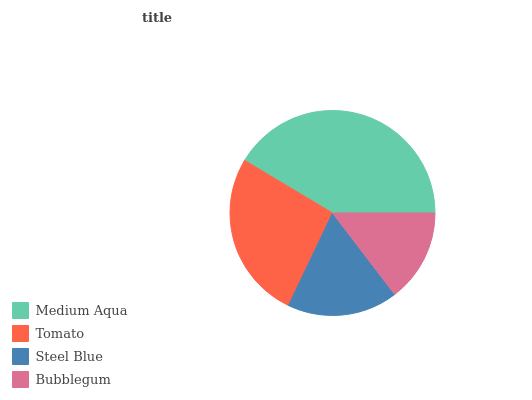Is Bubblegum the minimum?
Answer yes or no. Yes. Is Medium Aqua the maximum?
Answer yes or no. Yes. Is Tomato the minimum?
Answer yes or no. No. Is Tomato the maximum?
Answer yes or no. No. Is Medium Aqua greater than Tomato?
Answer yes or no. Yes. Is Tomato less than Medium Aqua?
Answer yes or no. Yes. Is Tomato greater than Medium Aqua?
Answer yes or no. No. Is Medium Aqua less than Tomato?
Answer yes or no. No. Is Tomato the high median?
Answer yes or no. Yes. Is Steel Blue the low median?
Answer yes or no. Yes. Is Medium Aqua the high median?
Answer yes or no. No. Is Tomato the low median?
Answer yes or no. No. 